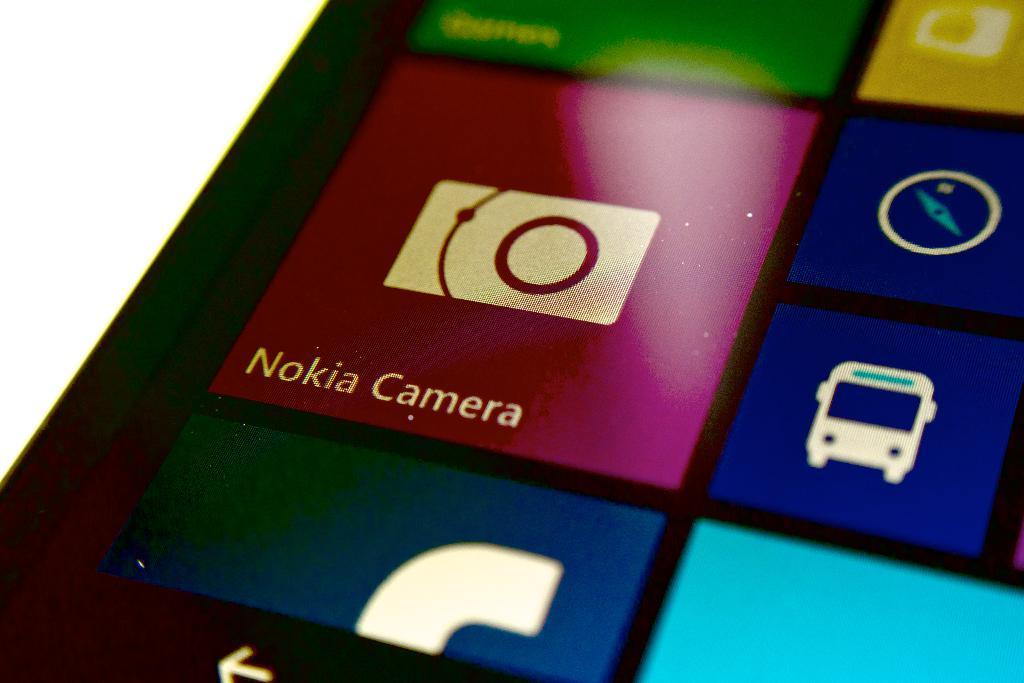Provide a one-sentence caption for the provided image. A maroon icon shows a picture of a camera with Nokia Camera written underneath it. 